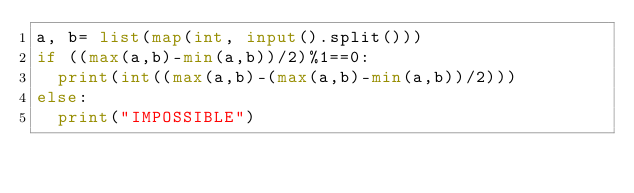Convert code to text. <code><loc_0><loc_0><loc_500><loc_500><_Python_>a, b= list(map(int, input().split()))
if ((max(a,b)-min(a,b))/2)%1==0:
  print(int((max(a,b)-(max(a,b)-min(a,b))/2)))
else:
  print("IMPOSSIBLE")</code> 